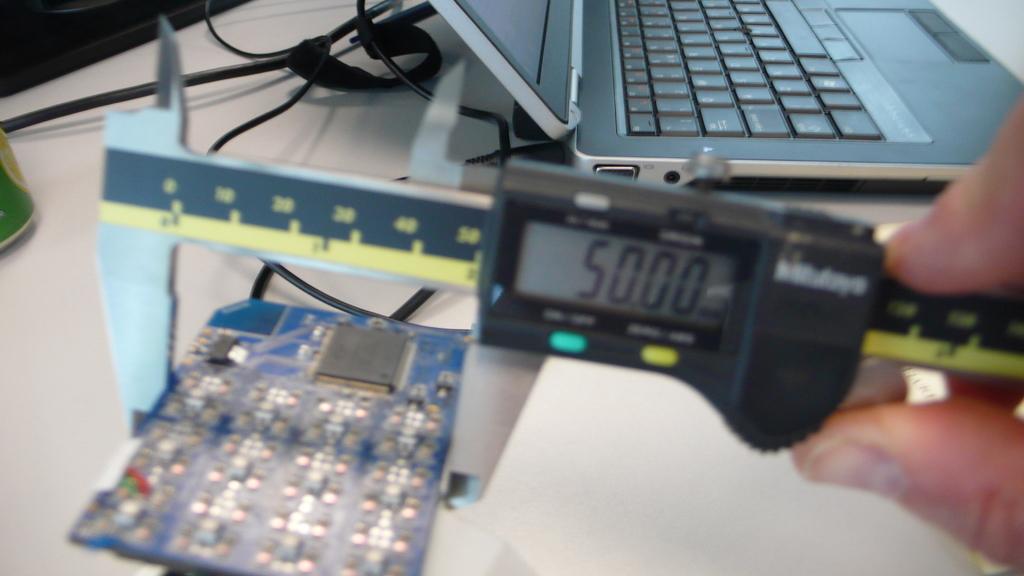What number is on the digital screen?
Offer a very short reply. 50.00. 